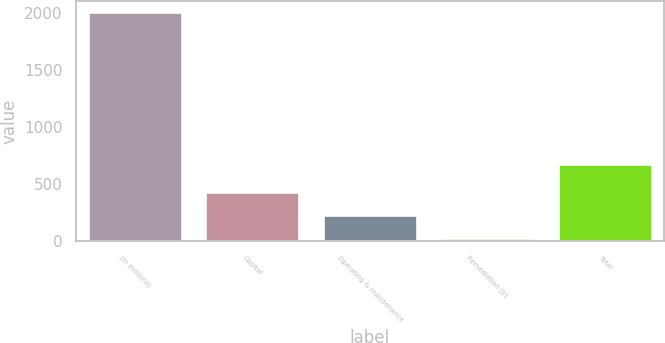Convert chart. <chart><loc_0><loc_0><loc_500><loc_500><bar_chart><fcel>(In millions)<fcel>Capital<fcel>Operating & maintenance<fcel>Remediation (b)<fcel>Total<nl><fcel>2004<fcel>433<fcel>229.2<fcel>32<fcel>680<nl></chart> 